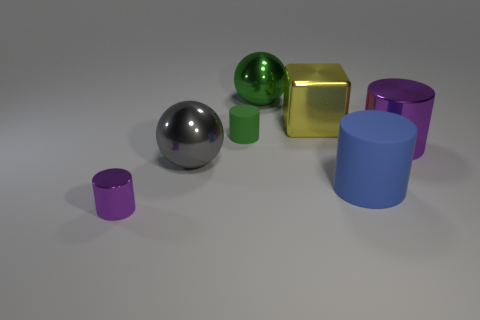Are there any patterns or consistencies among the objects? The objects seem to be consistently geometric in nature. They include shapes like spheres, a cube, and cylinders. This selection of objects reflects a simple yet effective demonstration of geometric forms, possibly for educational or display purposes. 